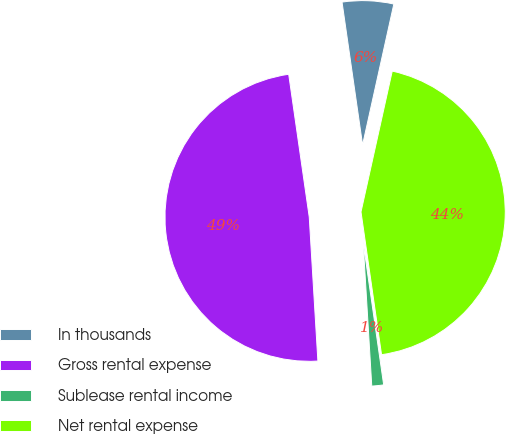<chart> <loc_0><loc_0><loc_500><loc_500><pie_chart><fcel>In thousands<fcel>Gross rental expense<fcel>Sublease rental income<fcel>Net rental expense<nl><fcel>5.75%<fcel>48.68%<fcel>1.32%<fcel>44.25%<nl></chart> 